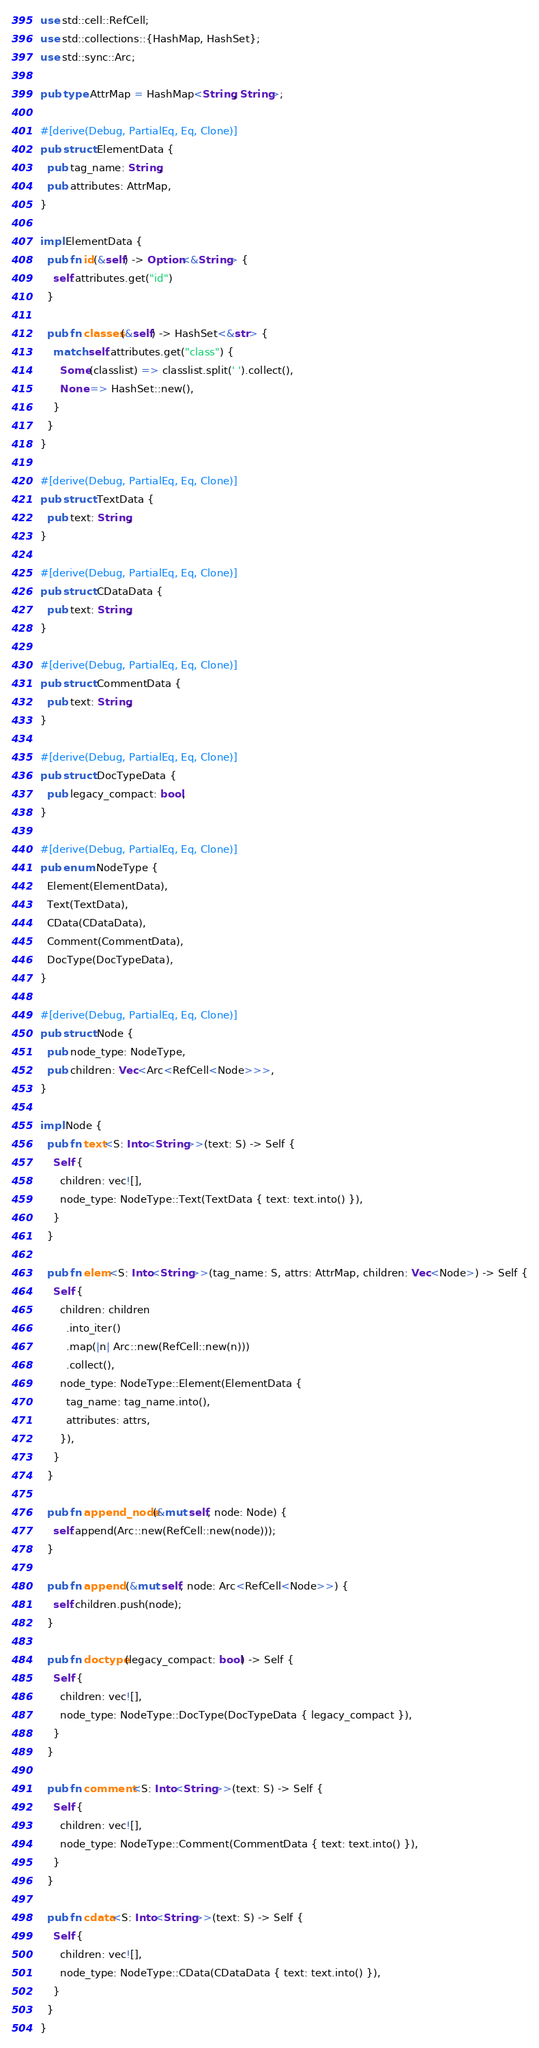Convert code to text. <code><loc_0><loc_0><loc_500><loc_500><_Rust_>use std::cell::RefCell;
use std::collections::{HashMap, HashSet};
use std::sync::Arc;

pub type AttrMap = HashMap<String, String>;

#[derive(Debug, PartialEq, Eq, Clone)]
pub struct ElementData {
  pub tag_name: String,
  pub attributes: AttrMap,
}

impl ElementData {
  pub fn id(&self) -> Option<&String> {
    self.attributes.get("id")
  }

  pub fn classes(&self) -> HashSet<&str> {
    match self.attributes.get("class") {
      Some(classlist) => classlist.split(' ').collect(),
      None => HashSet::new(),
    }
  }
}

#[derive(Debug, PartialEq, Eq, Clone)]
pub struct TextData {
  pub text: String,
}

#[derive(Debug, PartialEq, Eq, Clone)]
pub struct CDataData {
  pub text: String,
}

#[derive(Debug, PartialEq, Eq, Clone)]
pub struct CommentData {
  pub text: String,
}

#[derive(Debug, PartialEq, Eq, Clone)]
pub struct DocTypeData {
  pub legacy_compact: bool,
}

#[derive(Debug, PartialEq, Eq, Clone)]
pub enum NodeType {
  Element(ElementData),
  Text(TextData),
  CData(CDataData),
  Comment(CommentData),
  DocType(DocTypeData),
}

#[derive(Debug, PartialEq, Eq, Clone)]
pub struct Node {
  pub node_type: NodeType,
  pub children: Vec<Arc<RefCell<Node>>>,
}

impl Node {
  pub fn text<S: Into<String>>(text: S) -> Self {
    Self {
      children: vec![],
      node_type: NodeType::Text(TextData { text: text.into() }),
    }
  }

  pub fn elem<S: Into<String>>(tag_name: S, attrs: AttrMap, children: Vec<Node>) -> Self {
    Self {
      children: children
        .into_iter()
        .map(|n| Arc::new(RefCell::new(n)))
        .collect(),
      node_type: NodeType::Element(ElementData {
        tag_name: tag_name.into(),
        attributes: attrs,
      }),
    }
  }

  pub fn append_node(&mut self, node: Node) {
    self.append(Arc::new(RefCell::new(node)));
  }

  pub fn append (&mut self, node: Arc<RefCell<Node>>) {
    self.children.push(node);
  }

  pub fn doctype(legacy_compact: bool) -> Self {
    Self {
      children: vec![],
      node_type: NodeType::DocType(DocTypeData { legacy_compact }),
    }
  }

  pub fn comment<S: Into<String>>(text: S) -> Self {
    Self {
      children: vec![],
      node_type: NodeType::Comment(CommentData { text: text.into() }),
    }
  }

  pub fn cdata<S: Into<String>>(text: S) -> Self {
    Self {
      children: vec![],
      node_type: NodeType::CData(CDataData { text: text.into() }),
    }
  }
}
</code> 